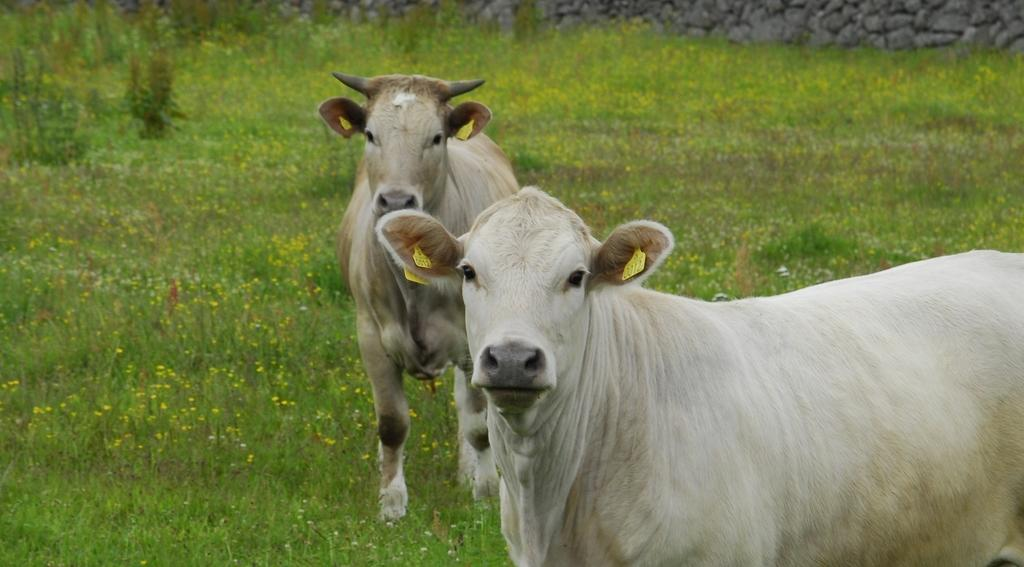How many cows are present in the image? There are two cows in the image. Where are the cows located in the image? The cows are standing in a garden. What can be seen on the cows' ears? The cows have tags in their ears. What type of pear is being eaten by the cows in the image? There are no pears present in the image; the cows are standing in a garden with tags in their ears. 